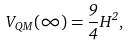Convert formula to latex. <formula><loc_0><loc_0><loc_500><loc_500>V _ { Q M } ( \infty ) = \frac { 9 } { 4 } H ^ { 2 } ,</formula> 